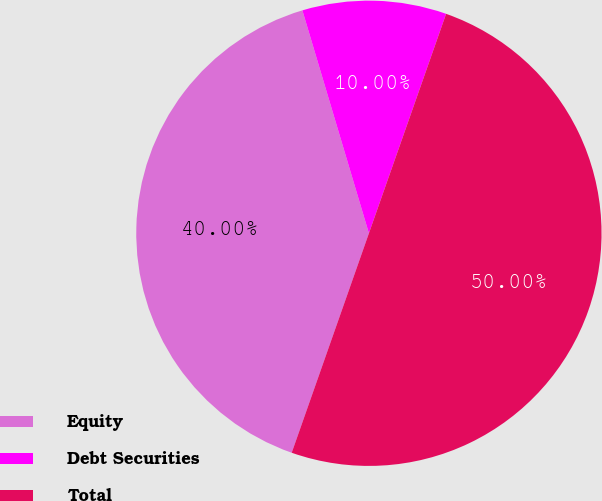<chart> <loc_0><loc_0><loc_500><loc_500><pie_chart><fcel>Equity<fcel>Debt Securities<fcel>Total<nl><fcel>40.0%<fcel>10.0%<fcel>50.0%<nl></chart> 